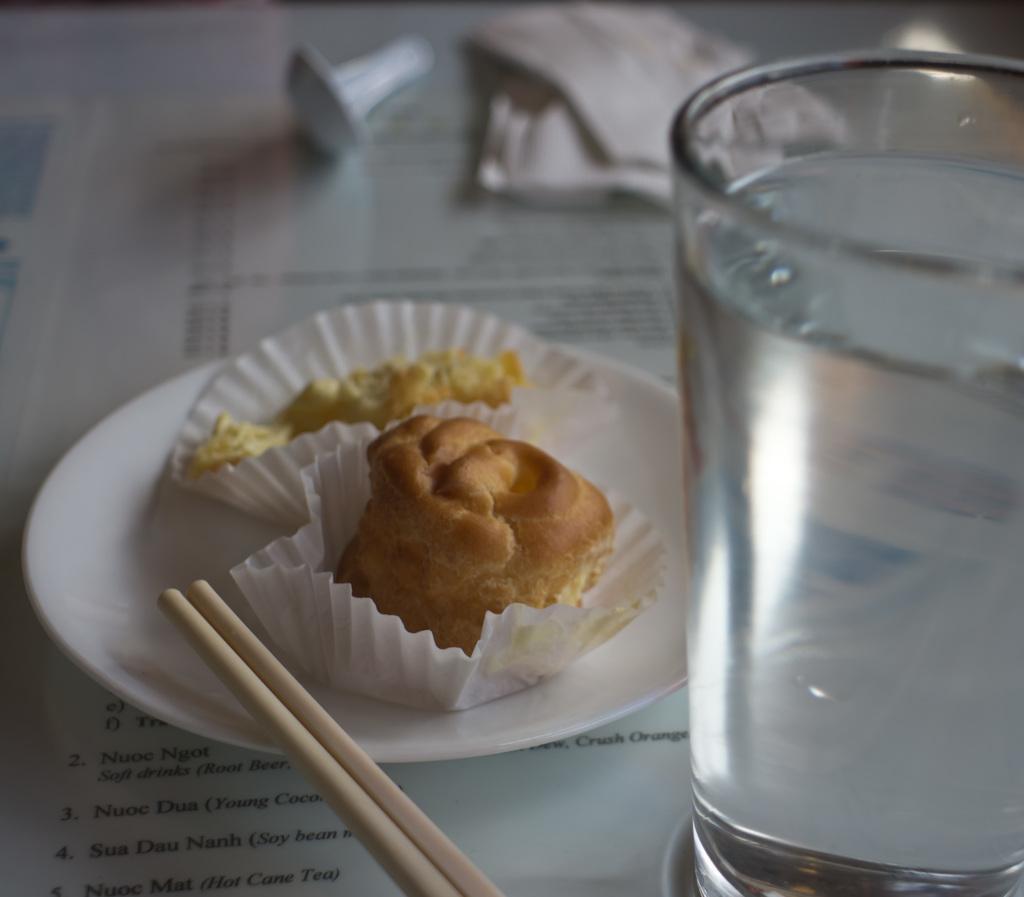Could you give a brief overview of what you see in this image? In this picture, we can see some objects on a surface like food items served in a plate, sticks, glass with water in it, we can see some blurred objects in the top side of the picture. 